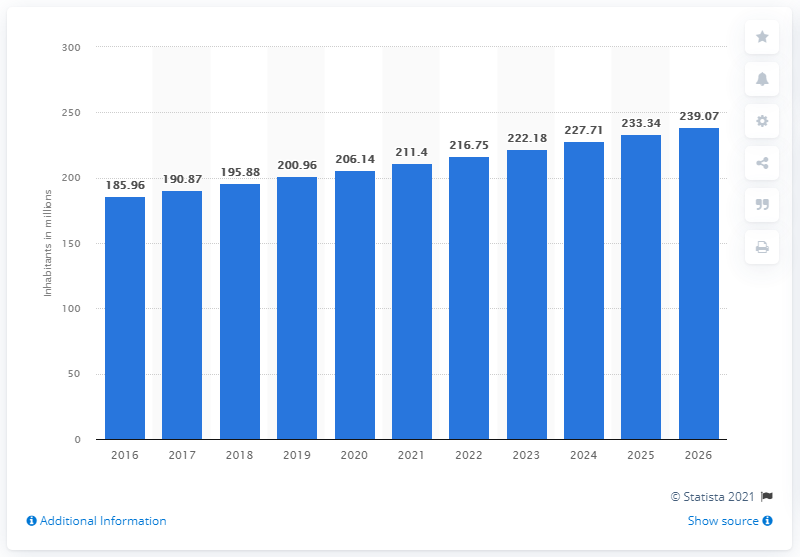Mention a couple of crucial points in this snapshot. In 2019, the population of Nigeria was approximately 200.96 million people. 